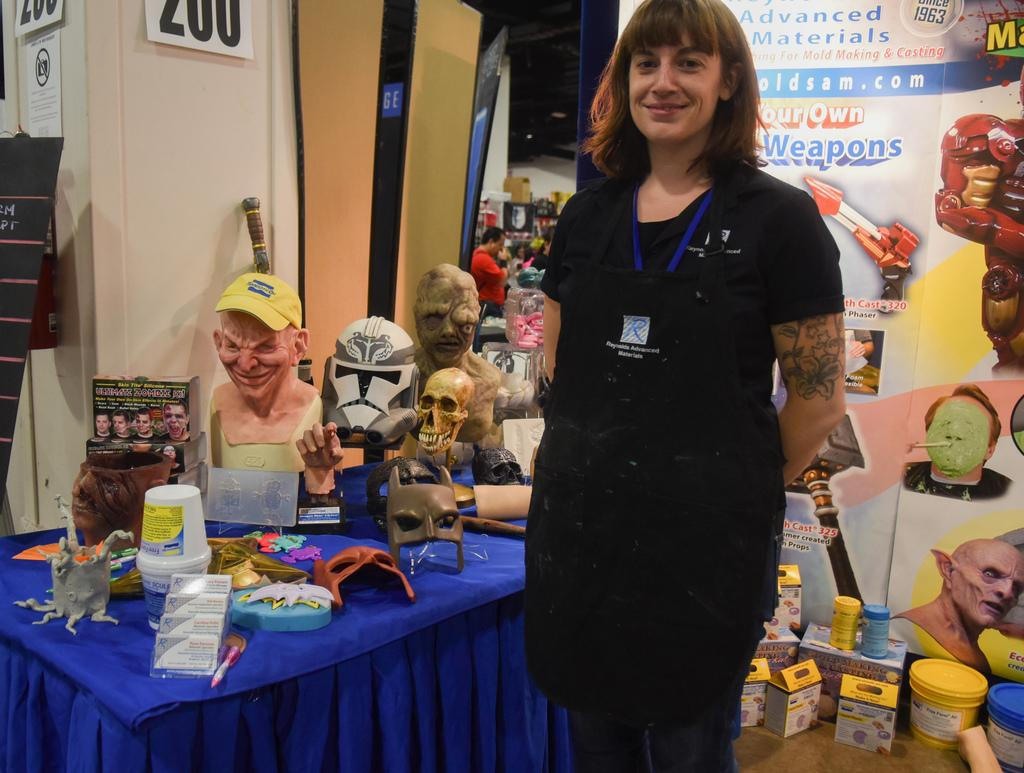What is the main subject of the image? There is a woman standing in the middle of the image. What is the woman's expression in the image? The woman is smiling. What is located behind the woman in the image? There is a table behind the woman. What items can be seen on the table in the image? There are masks and products on the table. What additional element is present in the image? There is a banner in the image. How does the woman slip on the waste in the image? There is no waste present in the image, so the woman does not slip. What company is responsible for the products on the table in the image? The image does not provide information about the company responsible for the products on the table. 